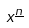Convert formula to latex. <formula><loc_0><loc_0><loc_500><loc_500>x ^ { \underline { n } }</formula> 